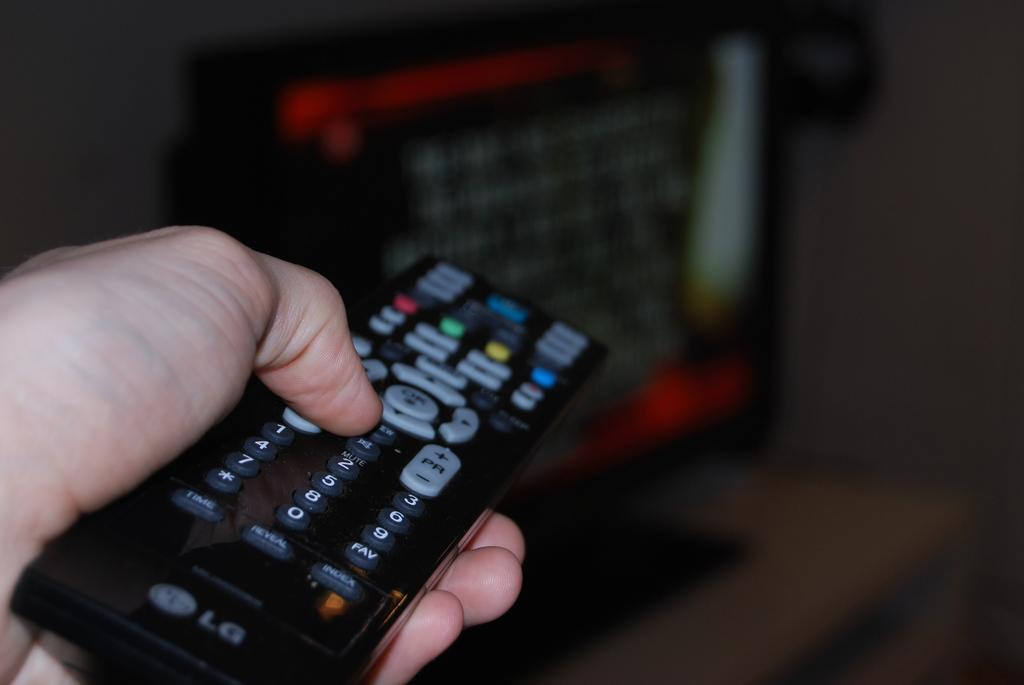<image>
Offer a succinct explanation of the picture presented. An LG brand remote control in a person's hand. 